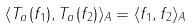Convert formula to latex. <formula><loc_0><loc_0><loc_500><loc_500>\langle T _ { a } ( f _ { 1 } ) , T _ { a } ( f _ { 2 } ) \rangle _ { A } = \langle f _ { 1 } , f _ { 2 } \rangle _ { A }</formula> 